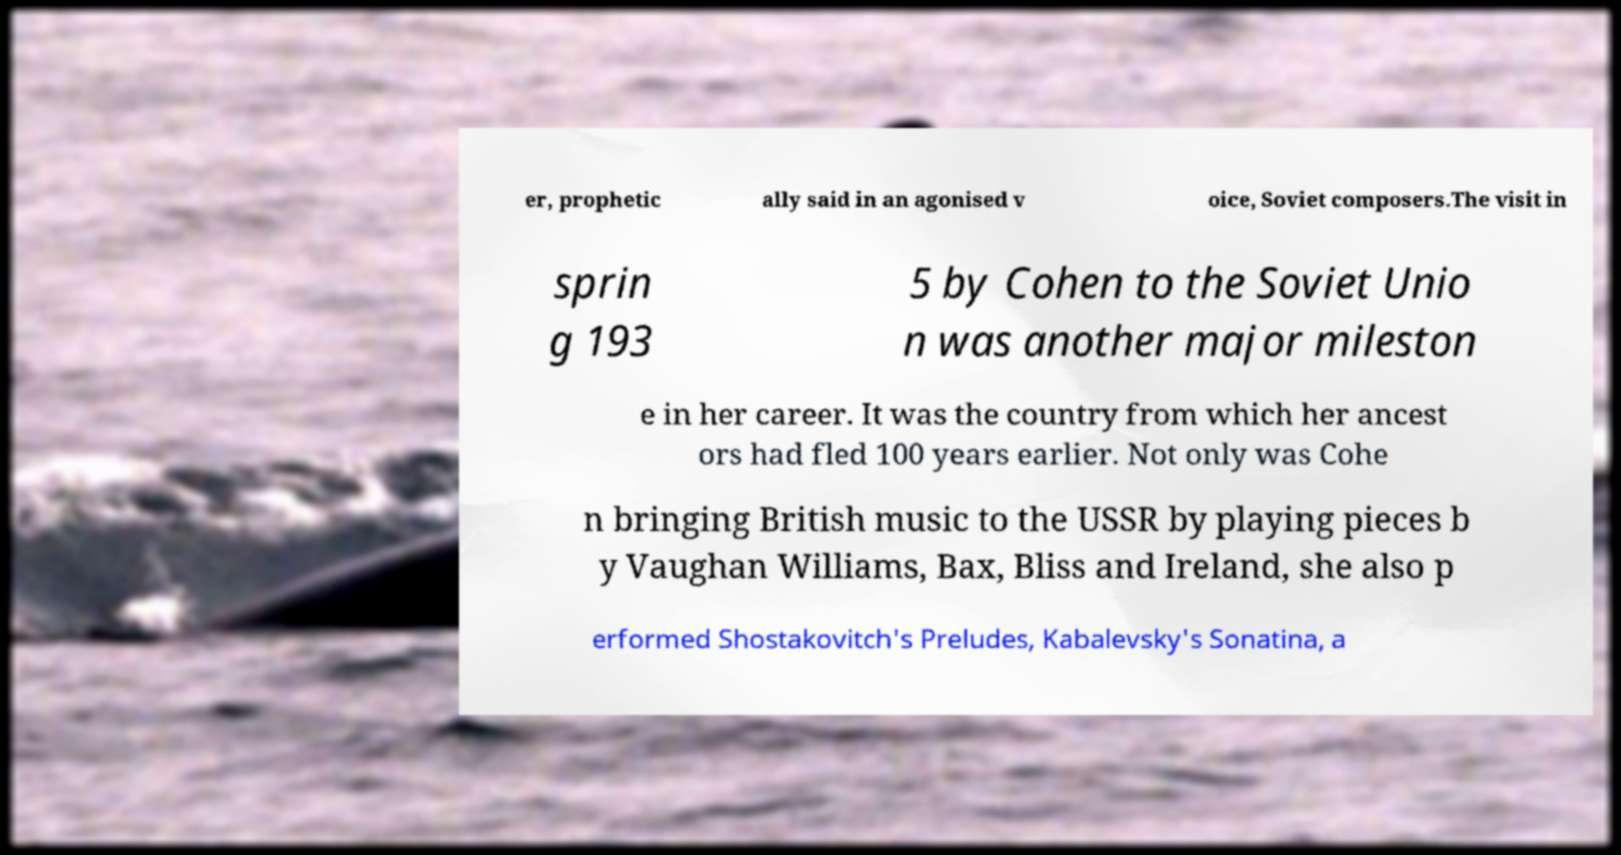Can you accurately transcribe the text from the provided image for me? er, prophetic ally said in an agonised v oice, Soviet composers.The visit in sprin g 193 5 by Cohen to the Soviet Unio n was another major mileston e in her career. It was the country from which her ancest ors had fled 100 years earlier. Not only was Cohe n bringing British music to the USSR by playing pieces b y Vaughan Williams, Bax, Bliss and Ireland, she also p erformed Shostakovitch's Preludes, Kabalevsky's Sonatina, a 